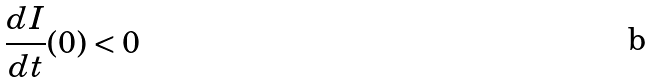<formula> <loc_0><loc_0><loc_500><loc_500>\frac { d I } { d t } ( 0 ) < 0</formula> 